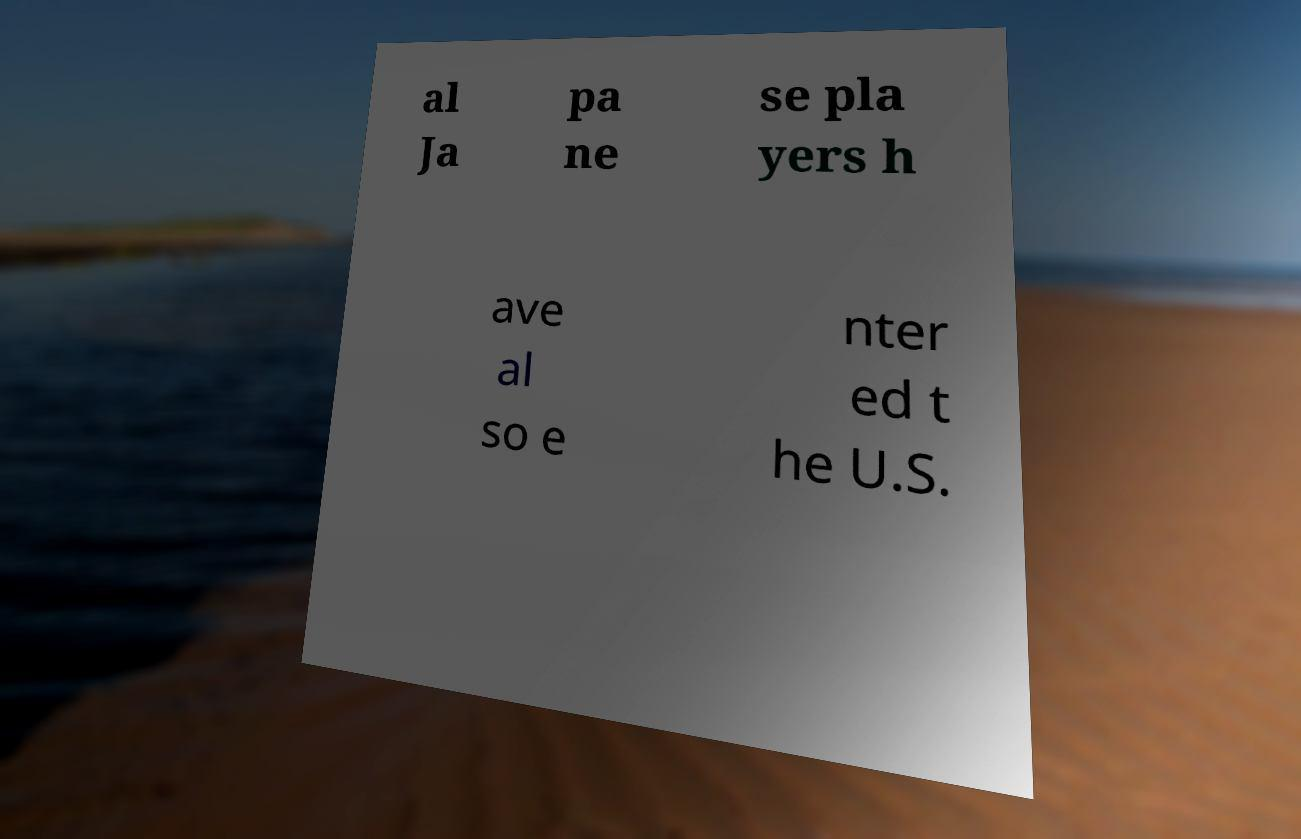Can you read and provide the text displayed in the image?This photo seems to have some interesting text. Can you extract and type it out for me? al Ja pa ne se pla yers h ave al so e nter ed t he U.S. 